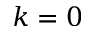<formula> <loc_0><loc_0><loc_500><loc_500>k = 0</formula> 